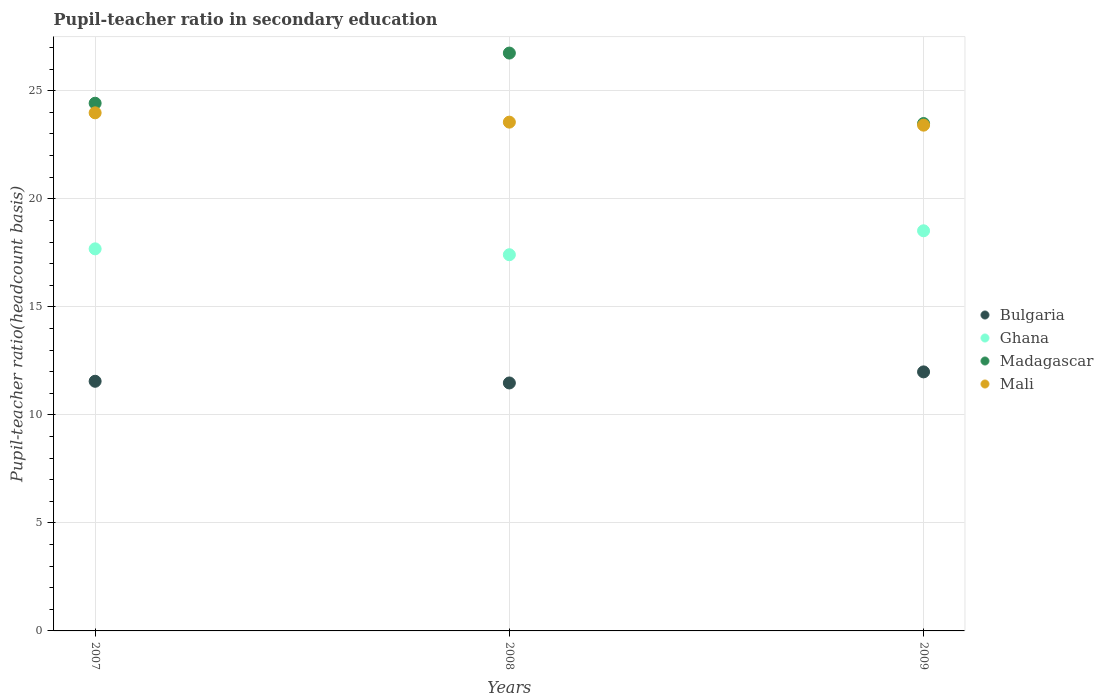How many different coloured dotlines are there?
Provide a succinct answer. 4. Is the number of dotlines equal to the number of legend labels?
Your answer should be very brief. Yes. What is the pupil-teacher ratio in secondary education in Mali in 2007?
Ensure brevity in your answer.  23.98. Across all years, what is the maximum pupil-teacher ratio in secondary education in Ghana?
Offer a very short reply. 18.52. Across all years, what is the minimum pupil-teacher ratio in secondary education in Ghana?
Your answer should be compact. 17.41. In which year was the pupil-teacher ratio in secondary education in Madagascar maximum?
Keep it short and to the point. 2008. What is the total pupil-teacher ratio in secondary education in Bulgaria in the graph?
Offer a very short reply. 35.02. What is the difference between the pupil-teacher ratio in secondary education in Madagascar in 2008 and that in 2009?
Your answer should be very brief. 3.26. What is the difference between the pupil-teacher ratio in secondary education in Madagascar in 2009 and the pupil-teacher ratio in secondary education in Ghana in 2007?
Provide a succinct answer. 5.8. What is the average pupil-teacher ratio in secondary education in Bulgaria per year?
Provide a succinct answer. 11.67. In the year 2007, what is the difference between the pupil-teacher ratio in secondary education in Madagascar and pupil-teacher ratio in secondary education in Mali?
Your response must be concise. 0.44. What is the ratio of the pupil-teacher ratio in secondary education in Ghana in 2008 to that in 2009?
Offer a very short reply. 0.94. Is the pupil-teacher ratio in secondary education in Bulgaria in 2007 less than that in 2009?
Provide a short and direct response. Yes. Is the difference between the pupil-teacher ratio in secondary education in Madagascar in 2008 and 2009 greater than the difference between the pupil-teacher ratio in secondary education in Mali in 2008 and 2009?
Offer a terse response. Yes. What is the difference between the highest and the second highest pupil-teacher ratio in secondary education in Ghana?
Your answer should be very brief. 0.84. What is the difference between the highest and the lowest pupil-teacher ratio in secondary education in Bulgaria?
Your answer should be very brief. 0.51. In how many years, is the pupil-teacher ratio in secondary education in Mali greater than the average pupil-teacher ratio in secondary education in Mali taken over all years?
Your answer should be very brief. 1. Is the sum of the pupil-teacher ratio in secondary education in Ghana in 2007 and 2009 greater than the maximum pupil-teacher ratio in secondary education in Madagascar across all years?
Make the answer very short. Yes. Is it the case that in every year, the sum of the pupil-teacher ratio in secondary education in Bulgaria and pupil-teacher ratio in secondary education in Madagascar  is greater than the sum of pupil-teacher ratio in secondary education in Ghana and pupil-teacher ratio in secondary education in Mali?
Provide a short and direct response. No. Does the pupil-teacher ratio in secondary education in Mali monotonically increase over the years?
Make the answer very short. No. Is the pupil-teacher ratio in secondary education in Madagascar strictly greater than the pupil-teacher ratio in secondary education in Bulgaria over the years?
Offer a terse response. Yes. How many dotlines are there?
Offer a very short reply. 4. Are the values on the major ticks of Y-axis written in scientific E-notation?
Ensure brevity in your answer.  No. Does the graph contain grids?
Give a very brief answer. Yes. Where does the legend appear in the graph?
Make the answer very short. Center right. How are the legend labels stacked?
Your answer should be compact. Vertical. What is the title of the graph?
Your response must be concise. Pupil-teacher ratio in secondary education. What is the label or title of the X-axis?
Your answer should be compact. Years. What is the label or title of the Y-axis?
Your answer should be compact. Pupil-teacher ratio(headcount basis). What is the Pupil-teacher ratio(headcount basis) in Bulgaria in 2007?
Your answer should be compact. 11.55. What is the Pupil-teacher ratio(headcount basis) of Ghana in 2007?
Give a very brief answer. 17.68. What is the Pupil-teacher ratio(headcount basis) in Madagascar in 2007?
Provide a succinct answer. 24.42. What is the Pupil-teacher ratio(headcount basis) of Mali in 2007?
Give a very brief answer. 23.98. What is the Pupil-teacher ratio(headcount basis) of Bulgaria in 2008?
Ensure brevity in your answer.  11.48. What is the Pupil-teacher ratio(headcount basis) of Ghana in 2008?
Offer a very short reply. 17.41. What is the Pupil-teacher ratio(headcount basis) of Madagascar in 2008?
Give a very brief answer. 26.74. What is the Pupil-teacher ratio(headcount basis) of Mali in 2008?
Provide a succinct answer. 23.55. What is the Pupil-teacher ratio(headcount basis) of Bulgaria in 2009?
Your answer should be compact. 11.99. What is the Pupil-teacher ratio(headcount basis) of Ghana in 2009?
Provide a short and direct response. 18.52. What is the Pupil-teacher ratio(headcount basis) in Madagascar in 2009?
Make the answer very short. 23.48. What is the Pupil-teacher ratio(headcount basis) in Mali in 2009?
Offer a very short reply. 23.41. Across all years, what is the maximum Pupil-teacher ratio(headcount basis) in Bulgaria?
Your answer should be very brief. 11.99. Across all years, what is the maximum Pupil-teacher ratio(headcount basis) of Ghana?
Provide a succinct answer. 18.52. Across all years, what is the maximum Pupil-teacher ratio(headcount basis) in Madagascar?
Keep it short and to the point. 26.74. Across all years, what is the maximum Pupil-teacher ratio(headcount basis) in Mali?
Give a very brief answer. 23.98. Across all years, what is the minimum Pupil-teacher ratio(headcount basis) in Bulgaria?
Keep it short and to the point. 11.48. Across all years, what is the minimum Pupil-teacher ratio(headcount basis) of Ghana?
Keep it short and to the point. 17.41. Across all years, what is the minimum Pupil-teacher ratio(headcount basis) in Madagascar?
Offer a very short reply. 23.48. Across all years, what is the minimum Pupil-teacher ratio(headcount basis) of Mali?
Your response must be concise. 23.41. What is the total Pupil-teacher ratio(headcount basis) in Bulgaria in the graph?
Your answer should be compact. 35.02. What is the total Pupil-teacher ratio(headcount basis) in Ghana in the graph?
Your answer should be very brief. 53.61. What is the total Pupil-teacher ratio(headcount basis) of Madagascar in the graph?
Ensure brevity in your answer.  74.65. What is the total Pupil-teacher ratio(headcount basis) of Mali in the graph?
Offer a very short reply. 70.94. What is the difference between the Pupil-teacher ratio(headcount basis) in Bulgaria in 2007 and that in 2008?
Provide a short and direct response. 0.08. What is the difference between the Pupil-teacher ratio(headcount basis) in Ghana in 2007 and that in 2008?
Your answer should be compact. 0.27. What is the difference between the Pupil-teacher ratio(headcount basis) in Madagascar in 2007 and that in 2008?
Provide a short and direct response. -2.32. What is the difference between the Pupil-teacher ratio(headcount basis) in Mali in 2007 and that in 2008?
Offer a terse response. 0.43. What is the difference between the Pupil-teacher ratio(headcount basis) of Bulgaria in 2007 and that in 2009?
Provide a short and direct response. -0.43. What is the difference between the Pupil-teacher ratio(headcount basis) in Ghana in 2007 and that in 2009?
Keep it short and to the point. -0.84. What is the difference between the Pupil-teacher ratio(headcount basis) in Madagascar in 2007 and that in 2009?
Your answer should be compact. 0.94. What is the difference between the Pupil-teacher ratio(headcount basis) in Mali in 2007 and that in 2009?
Make the answer very short. 0.57. What is the difference between the Pupil-teacher ratio(headcount basis) in Bulgaria in 2008 and that in 2009?
Give a very brief answer. -0.51. What is the difference between the Pupil-teacher ratio(headcount basis) of Ghana in 2008 and that in 2009?
Provide a succinct answer. -1.11. What is the difference between the Pupil-teacher ratio(headcount basis) in Madagascar in 2008 and that in 2009?
Ensure brevity in your answer.  3.26. What is the difference between the Pupil-teacher ratio(headcount basis) of Mali in 2008 and that in 2009?
Keep it short and to the point. 0.14. What is the difference between the Pupil-teacher ratio(headcount basis) in Bulgaria in 2007 and the Pupil-teacher ratio(headcount basis) in Ghana in 2008?
Provide a succinct answer. -5.86. What is the difference between the Pupil-teacher ratio(headcount basis) of Bulgaria in 2007 and the Pupil-teacher ratio(headcount basis) of Madagascar in 2008?
Offer a very short reply. -15.19. What is the difference between the Pupil-teacher ratio(headcount basis) of Bulgaria in 2007 and the Pupil-teacher ratio(headcount basis) of Mali in 2008?
Provide a succinct answer. -11.99. What is the difference between the Pupil-teacher ratio(headcount basis) in Ghana in 2007 and the Pupil-teacher ratio(headcount basis) in Madagascar in 2008?
Your response must be concise. -9.06. What is the difference between the Pupil-teacher ratio(headcount basis) of Ghana in 2007 and the Pupil-teacher ratio(headcount basis) of Mali in 2008?
Provide a succinct answer. -5.86. What is the difference between the Pupil-teacher ratio(headcount basis) in Madagascar in 2007 and the Pupil-teacher ratio(headcount basis) in Mali in 2008?
Your answer should be compact. 0.88. What is the difference between the Pupil-teacher ratio(headcount basis) in Bulgaria in 2007 and the Pupil-teacher ratio(headcount basis) in Ghana in 2009?
Offer a terse response. -6.97. What is the difference between the Pupil-teacher ratio(headcount basis) of Bulgaria in 2007 and the Pupil-teacher ratio(headcount basis) of Madagascar in 2009?
Offer a terse response. -11.93. What is the difference between the Pupil-teacher ratio(headcount basis) in Bulgaria in 2007 and the Pupil-teacher ratio(headcount basis) in Mali in 2009?
Provide a short and direct response. -11.85. What is the difference between the Pupil-teacher ratio(headcount basis) in Ghana in 2007 and the Pupil-teacher ratio(headcount basis) in Madagascar in 2009?
Your response must be concise. -5.8. What is the difference between the Pupil-teacher ratio(headcount basis) in Ghana in 2007 and the Pupil-teacher ratio(headcount basis) in Mali in 2009?
Provide a short and direct response. -5.73. What is the difference between the Pupil-teacher ratio(headcount basis) of Madagascar in 2007 and the Pupil-teacher ratio(headcount basis) of Mali in 2009?
Make the answer very short. 1.01. What is the difference between the Pupil-teacher ratio(headcount basis) of Bulgaria in 2008 and the Pupil-teacher ratio(headcount basis) of Ghana in 2009?
Give a very brief answer. -7.04. What is the difference between the Pupil-teacher ratio(headcount basis) in Bulgaria in 2008 and the Pupil-teacher ratio(headcount basis) in Madagascar in 2009?
Provide a succinct answer. -12.01. What is the difference between the Pupil-teacher ratio(headcount basis) in Bulgaria in 2008 and the Pupil-teacher ratio(headcount basis) in Mali in 2009?
Provide a short and direct response. -11.93. What is the difference between the Pupil-teacher ratio(headcount basis) in Ghana in 2008 and the Pupil-teacher ratio(headcount basis) in Madagascar in 2009?
Ensure brevity in your answer.  -6.07. What is the difference between the Pupil-teacher ratio(headcount basis) in Ghana in 2008 and the Pupil-teacher ratio(headcount basis) in Mali in 2009?
Provide a succinct answer. -6. What is the difference between the Pupil-teacher ratio(headcount basis) in Madagascar in 2008 and the Pupil-teacher ratio(headcount basis) in Mali in 2009?
Your answer should be compact. 3.34. What is the average Pupil-teacher ratio(headcount basis) of Bulgaria per year?
Keep it short and to the point. 11.67. What is the average Pupil-teacher ratio(headcount basis) in Ghana per year?
Make the answer very short. 17.87. What is the average Pupil-teacher ratio(headcount basis) of Madagascar per year?
Your response must be concise. 24.88. What is the average Pupil-teacher ratio(headcount basis) of Mali per year?
Your response must be concise. 23.65. In the year 2007, what is the difference between the Pupil-teacher ratio(headcount basis) in Bulgaria and Pupil-teacher ratio(headcount basis) in Ghana?
Ensure brevity in your answer.  -6.13. In the year 2007, what is the difference between the Pupil-teacher ratio(headcount basis) of Bulgaria and Pupil-teacher ratio(headcount basis) of Madagascar?
Your answer should be compact. -12.87. In the year 2007, what is the difference between the Pupil-teacher ratio(headcount basis) of Bulgaria and Pupil-teacher ratio(headcount basis) of Mali?
Give a very brief answer. -12.42. In the year 2007, what is the difference between the Pupil-teacher ratio(headcount basis) in Ghana and Pupil-teacher ratio(headcount basis) in Madagascar?
Offer a terse response. -6.74. In the year 2007, what is the difference between the Pupil-teacher ratio(headcount basis) in Ghana and Pupil-teacher ratio(headcount basis) in Mali?
Make the answer very short. -6.3. In the year 2007, what is the difference between the Pupil-teacher ratio(headcount basis) in Madagascar and Pupil-teacher ratio(headcount basis) in Mali?
Your response must be concise. 0.44. In the year 2008, what is the difference between the Pupil-teacher ratio(headcount basis) in Bulgaria and Pupil-teacher ratio(headcount basis) in Ghana?
Your answer should be very brief. -5.94. In the year 2008, what is the difference between the Pupil-teacher ratio(headcount basis) in Bulgaria and Pupil-teacher ratio(headcount basis) in Madagascar?
Ensure brevity in your answer.  -15.27. In the year 2008, what is the difference between the Pupil-teacher ratio(headcount basis) in Bulgaria and Pupil-teacher ratio(headcount basis) in Mali?
Ensure brevity in your answer.  -12.07. In the year 2008, what is the difference between the Pupil-teacher ratio(headcount basis) in Ghana and Pupil-teacher ratio(headcount basis) in Madagascar?
Keep it short and to the point. -9.33. In the year 2008, what is the difference between the Pupil-teacher ratio(headcount basis) in Ghana and Pupil-teacher ratio(headcount basis) in Mali?
Provide a short and direct response. -6.14. In the year 2008, what is the difference between the Pupil-teacher ratio(headcount basis) in Madagascar and Pupil-teacher ratio(headcount basis) in Mali?
Provide a short and direct response. 3.2. In the year 2009, what is the difference between the Pupil-teacher ratio(headcount basis) of Bulgaria and Pupil-teacher ratio(headcount basis) of Ghana?
Your response must be concise. -6.53. In the year 2009, what is the difference between the Pupil-teacher ratio(headcount basis) of Bulgaria and Pupil-teacher ratio(headcount basis) of Madagascar?
Make the answer very short. -11.49. In the year 2009, what is the difference between the Pupil-teacher ratio(headcount basis) of Bulgaria and Pupil-teacher ratio(headcount basis) of Mali?
Keep it short and to the point. -11.42. In the year 2009, what is the difference between the Pupil-teacher ratio(headcount basis) of Ghana and Pupil-teacher ratio(headcount basis) of Madagascar?
Make the answer very short. -4.96. In the year 2009, what is the difference between the Pupil-teacher ratio(headcount basis) of Ghana and Pupil-teacher ratio(headcount basis) of Mali?
Offer a terse response. -4.89. In the year 2009, what is the difference between the Pupil-teacher ratio(headcount basis) of Madagascar and Pupil-teacher ratio(headcount basis) of Mali?
Provide a short and direct response. 0.07. What is the ratio of the Pupil-teacher ratio(headcount basis) in Bulgaria in 2007 to that in 2008?
Keep it short and to the point. 1.01. What is the ratio of the Pupil-teacher ratio(headcount basis) in Ghana in 2007 to that in 2008?
Provide a short and direct response. 1.02. What is the ratio of the Pupil-teacher ratio(headcount basis) in Madagascar in 2007 to that in 2008?
Ensure brevity in your answer.  0.91. What is the ratio of the Pupil-teacher ratio(headcount basis) in Mali in 2007 to that in 2008?
Give a very brief answer. 1.02. What is the ratio of the Pupil-teacher ratio(headcount basis) of Bulgaria in 2007 to that in 2009?
Make the answer very short. 0.96. What is the ratio of the Pupil-teacher ratio(headcount basis) in Ghana in 2007 to that in 2009?
Offer a very short reply. 0.95. What is the ratio of the Pupil-teacher ratio(headcount basis) in Mali in 2007 to that in 2009?
Provide a succinct answer. 1.02. What is the ratio of the Pupil-teacher ratio(headcount basis) of Bulgaria in 2008 to that in 2009?
Your response must be concise. 0.96. What is the ratio of the Pupil-teacher ratio(headcount basis) in Ghana in 2008 to that in 2009?
Keep it short and to the point. 0.94. What is the ratio of the Pupil-teacher ratio(headcount basis) in Madagascar in 2008 to that in 2009?
Keep it short and to the point. 1.14. What is the ratio of the Pupil-teacher ratio(headcount basis) of Mali in 2008 to that in 2009?
Offer a terse response. 1.01. What is the difference between the highest and the second highest Pupil-teacher ratio(headcount basis) in Bulgaria?
Offer a terse response. 0.43. What is the difference between the highest and the second highest Pupil-teacher ratio(headcount basis) in Ghana?
Provide a short and direct response. 0.84. What is the difference between the highest and the second highest Pupil-teacher ratio(headcount basis) in Madagascar?
Your answer should be very brief. 2.32. What is the difference between the highest and the second highest Pupil-teacher ratio(headcount basis) of Mali?
Ensure brevity in your answer.  0.43. What is the difference between the highest and the lowest Pupil-teacher ratio(headcount basis) of Bulgaria?
Offer a terse response. 0.51. What is the difference between the highest and the lowest Pupil-teacher ratio(headcount basis) in Ghana?
Provide a short and direct response. 1.11. What is the difference between the highest and the lowest Pupil-teacher ratio(headcount basis) in Madagascar?
Provide a succinct answer. 3.26. What is the difference between the highest and the lowest Pupil-teacher ratio(headcount basis) of Mali?
Offer a very short reply. 0.57. 